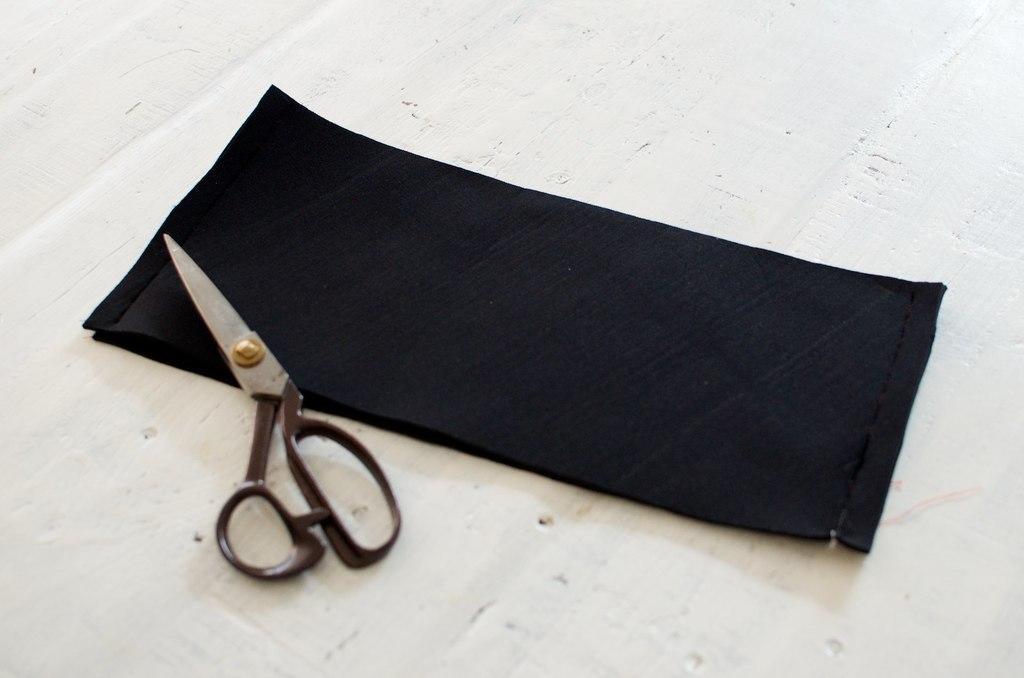How would you summarize this image in a sentence or two? This is a zoomed in picture. In the center there is a black color cloth and a scissors is placed on the top of an object. 